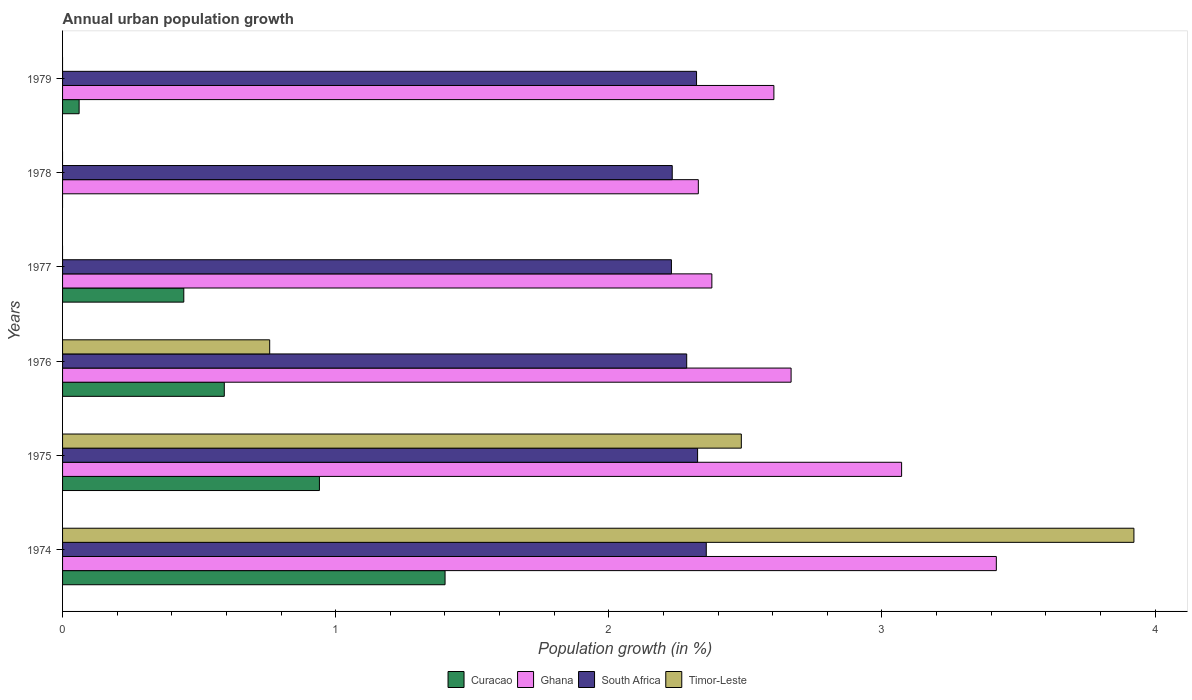Are the number of bars per tick equal to the number of legend labels?
Provide a succinct answer. No. How many bars are there on the 1st tick from the top?
Your response must be concise. 3. How many bars are there on the 2nd tick from the bottom?
Your response must be concise. 4. What is the label of the 3rd group of bars from the top?
Your response must be concise. 1977. In how many cases, is the number of bars for a given year not equal to the number of legend labels?
Provide a succinct answer. 3. What is the percentage of urban population growth in Timor-Leste in 1978?
Your answer should be very brief. 0. Across all years, what is the maximum percentage of urban population growth in Curacao?
Make the answer very short. 1.4. Across all years, what is the minimum percentage of urban population growth in South Africa?
Give a very brief answer. 2.23. In which year was the percentage of urban population growth in South Africa maximum?
Your response must be concise. 1974. What is the total percentage of urban population growth in Curacao in the graph?
Offer a terse response. 3.44. What is the difference between the percentage of urban population growth in Ghana in 1974 and that in 1978?
Provide a succinct answer. 1.09. What is the difference between the percentage of urban population growth in South Africa in 1978 and the percentage of urban population growth in Timor-Leste in 1974?
Give a very brief answer. -1.69. What is the average percentage of urban population growth in Timor-Leste per year?
Ensure brevity in your answer.  1.19. In the year 1977, what is the difference between the percentage of urban population growth in Curacao and percentage of urban population growth in Ghana?
Your response must be concise. -1.93. What is the ratio of the percentage of urban population growth in South Africa in 1974 to that in 1979?
Offer a terse response. 1.02. What is the difference between the highest and the second highest percentage of urban population growth in Ghana?
Your answer should be very brief. 0.35. What is the difference between the highest and the lowest percentage of urban population growth in South Africa?
Give a very brief answer. 0.13. Is the sum of the percentage of urban population growth in Ghana in 1974 and 1979 greater than the maximum percentage of urban population growth in Timor-Leste across all years?
Offer a terse response. Yes. Are all the bars in the graph horizontal?
Your response must be concise. Yes. Are the values on the major ticks of X-axis written in scientific E-notation?
Keep it short and to the point. No. Where does the legend appear in the graph?
Give a very brief answer. Bottom center. How many legend labels are there?
Your answer should be very brief. 4. How are the legend labels stacked?
Give a very brief answer. Horizontal. What is the title of the graph?
Give a very brief answer. Annual urban population growth. Does "Bhutan" appear as one of the legend labels in the graph?
Give a very brief answer. No. What is the label or title of the X-axis?
Keep it short and to the point. Population growth (in %). What is the label or title of the Y-axis?
Provide a succinct answer. Years. What is the Population growth (in %) of Curacao in 1974?
Make the answer very short. 1.4. What is the Population growth (in %) of Ghana in 1974?
Ensure brevity in your answer.  3.42. What is the Population growth (in %) in South Africa in 1974?
Your answer should be very brief. 2.36. What is the Population growth (in %) of Timor-Leste in 1974?
Your answer should be compact. 3.92. What is the Population growth (in %) in Curacao in 1975?
Make the answer very short. 0.94. What is the Population growth (in %) of Ghana in 1975?
Your response must be concise. 3.07. What is the Population growth (in %) of South Africa in 1975?
Offer a very short reply. 2.33. What is the Population growth (in %) of Timor-Leste in 1975?
Make the answer very short. 2.49. What is the Population growth (in %) of Curacao in 1976?
Offer a very short reply. 0.59. What is the Population growth (in %) of Ghana in 1976?
Your answer should be compact. 2.67. What is the Population growth (in %) in South Africa in 1976?
Your answer should be compact. 2.29. What is the Population growth (in %) in Timor-Leste in 1976?
Offer a terse response. 0.76. What is the Population growth (in %) in Curacao in 1977?
Your response must be concise. 0.44. What is the Population growth (in %) in Ghana in 1977?
Make the answer very short. 2.38. What is the Population growth (in %) of South Africa in 1977?
Provide a short and direct response. 2.23. What is the Population growth (in %) in Curacao in 1978?
Provide a succinct answer. 0. What is the Population growth (in %) of Ghana in 1978?
Offer a very short reply. 2.33. What is the Population growth (in %) of South Africa in 1978?
Your answer should be compact. 2.23. What is the Population growth (in %) of Curacao in 1979?
Offer a terse response. 0.06. What is the Population growth (in %) of Ghana in 1979?
Make the answer very short. 2.6. What is the Population growth (in %) of South Africa in 1979?
Provide a succinct answer. 2.32. What is the Population growth (in %) of Timor-Leste in 1979?
Offer a very short reply. 0. Across all years, what is the maximum Population growth (in %) of Curacao?
Your answer should be very brief. 1.4. Across all years, what is the maximum Population growth (in %) of Ghana?
Make the answer very short. 3.42. Across all years, what is the maximum Population growth (in %) in South Africa?
Make the answer very short. 2.36. Across all years, what is the maximum Population growth (in %) of Timor-Leste?
Offer a very short reply. 3.92. Across all years, what is the minimum Population growth (in %) of Curacao?
Provide a short and direct response. 0. Across all years, what is the minimum Population growth (in %) of Ghana?
Make the answer very short. 2.33. Across all years, what is the minimum Population growth (in %) of South Africa?
Keep it short and to the point. 2.23. Across all years, what is the minimum Population growth (in %) in Timor-Leste?
Offer a terse response. 0. What is the total Population growth (in %) of Curacao in the graph?
Your answer should be very brief. 3.44. What is the total Population growth (in %) of Ghana in the graph?
Offer a terse response. 16.47. What is the total Population growth (in %) of South Africa in the graph?
Give a very brief answer. 13.75. What is the total Population growth (in %) of Timor-Leste in the graph?
Give a very brief answer. 7.17. What is the difference between the Population growth (in %) of Curacao in 1974 and that in 1975?
Provide a short and direct response. 0.46. What is the difference between the Population growth (in %) of Ghana in 1974 and that in 1975?
Keep it short and to the point. 0.35. What is the difference between the Population growth (in %) in South Africa in 1974 and that in 1975?
Offer a terse response. 0.03. What is the difference between the Population growth (in %) of Timor-Leste in 1974 and that in 1975?
Your answer should be very brief. 1.44. What is the difference between the Population growth (in %) of Curacao in 1974 and that in 1976?
Your response must be concise. 0.81. What is the difference between the Population growth (in %) in Ghana in 1974 and that in 1976?
Your response must be concise. 0.75. What is the difference between the Population growth (in %) of South Africa in 1974 and that in 1976?
Provide a short and direct response. 0.07. What is the difference between the Population growth (in %) of Timor-Leste in 1974 and that in 1976?
Provide a short and direct response. 3.16. What is the difference between the Population growth (in %) in Curacao in 1974 and that in 1977?
Give a very brief answer. 0.96. What is the difference between the Population growth (in %) in Ghana in 1974 and that in 1977?
Make the answer very short. 1.04. What is the difference between the Population growth (in %) in South Africa in 1974 and that in 1977?
Give a very brief answer. 0.13. What is the difference between the Population growth (in %) in Ghana in 1974 and that in 1978?
Give a very brief answer. 1.09. What is the difference between the Population growth (in %) in South Africa in 1974 and that in 1978?
Your answer should be compact. 0.12. What is the difference between the Population growth (in %) in Curacao in 1974 and that in 1979?
Your answer should be compact. 1.34. What is the difference between the Population growth (in %) in Ghana in 1974 and that in 1979?
Offer a terse response. 0.81. What is the difference between the Population growth (in %) of South Africa in 1974 and that in 1979?
Your response must be concise. 0.04. What is the difference between the Population growth (in %) of Curacao in 1975 and that in 1976?
Keep it short and to the point. 0.35. What is the difference between the Population growth (in %) of Ghana in 1975 and that in 1976?
Your answer should be compact. 0.4. What is the difference between the Population growth (in %) in South Africa in 1975 and that in 1976?
Provide a short and direct response. 0.04. What is the difference between the Population growth (in %) in Timor-Leste in 1975 and that in 1976?
Ensure brevity in your answer.  1.73. What is the difference between the Population growth (in %) of Curacao in 1975 and that in 1977?
Offer a very short reply. 0.5. What is the difference between the Population growth (in %) of Ghana in 1975 and that in 1977?
Keep it short and to the point. 0.69. What is the difference between the Population growth (in %) in South Africa in 1975 and that in 1977?
Offer a very short reply. 0.1. What is the difference between the Population growth (in %) of Ghana in 1975 and that in 1978?
Give a very brief answer. 0.74. What is the difference between the Population growth (in %) of South Africa in 1975 and that in 1978?
Keep it short and to the point. 0.09. What is the difference between the Population growth (in %) of Curacao in 1975 and that in 1979?
Your response must be concise. 0.88. What is the difference between the Population growth (in %) of Ghana in 1975 and that in 1979?
Make the answer very short. 0.47. What is the difference between the Population growth (in %) in South Africa in 1975 and that in 1979?
Your answer should be compact. 0. What is the difference between the Population growth (in %) of Curacao in 1976 and that in 1977?
Provide a short and direct response. 0.15. What is the difference between the Population growth (in %) in Ghana in 1976 and that in 1977?
Your answer should be compact. 0.29. What is the difference between the Population growth (in %) of South Africa in 1976 and that in 1977?
Your answer should be very brief. 0.06. What is the difference between the Population growth (in %) in Ghana in 1976 and that in 1978?
Offer a terse response. 0.34. What is the difference between the Population growth (in %) in South Africa in 1976 and that in 1978?
Make the answer very short. 0.05. What is the difference between the Population growth (in %) in Curacao in 1976 and that in 1979?
Offer a very short reply. 0.53. What is the difference between the Population growth (in %) in Ghana in 1976 and that in 1979?
Provide a succinct answer. 0.06. What is the difference between the Population growth (in %) in South Africa in 1976 and that in 1979?
Provide a succinct answer. -0.04. What is the difference between the Population growth (in %) in Ghana in 1977 and that in 1978?
Make the answer very short. 0.05. What is the difference between the Population growth (in %) of South Africa in 1977 and that in 1978?
Your response must be concise. -0. What is the difference between the Population growth (in %) of Curacao in 1977 and that in 1979?
Give a very brief answer. 0.38. What is the difference between the Population growth (in %) of Ghana in 1977 and that in 1979?
Your answer should be compact. -0.23. What is the difference between the Population growth (in %) of South Africa in 1977 and that in 1979?
Offer a very short reply. -0.09. What is the difference between the Population growth (in %) in Ghana in 1978 and that in 1979?
Your answer should be compact. -0.28. What is the difference between the Population growth (in %) in South Africa in 1978 and that in 1979?
Give a very brief answer. -0.09. What is the difference between the Population growth (in %) in Curacao in 1974 and the Population growth (in %) in Ghana in 1975?
Provide a succinct answer. -1.67. What is the difference between the Population growth (in %) of Curacao in 1974 and the Population growth (in %) of South Africa in 1975?
Keep it short and to the point. -0.92. What is the difference between the Population growth (in %) of Curacao in 1974 and the Population growth (in %) of Timor-Leste in 1975?
Provide a short and direct response. -1.08. What is the difference between the Population growth (in %) of Ghana in 1974 and the Population growth (in %) of South Africa in 1975?
Your response must be concise. 1.09. What is the difference between the Population growth (in %) of Ghana in 1974 and the Population growth (in %) of Timor-Leste in 1975?
Your response must be concise. 0.93. What is the difference between the Population growth (in %) in South Africa in 1974 and the Population growth (in %) in Timor-Leste in 1975?
Keep it short and to the point. -0.13. What is the difference between the Population growth (in %) in Curacao in 1974 and the Population growth (in %) in Ghana in 1976?
Provide a short and direct response. -1.27. What is the difference between the Population growth (in %) of Curacao in 1974 and the Population growth (in %) of South Africa in 1976?
Offer a terse response. -0.88. What is the difference between the Population growth (in %) of Curacao in 1974 and the Population growth (in %) of Timor-Leste in 1976?
Your response must be concise. 0.64. What is the difference between the Population growth (in %) in Ghana in 1974 and the Population growth (in %) in South Africa in 1976?
Make the answer very short. 1.13. What is the difference between the Population growth (in %) in Ghana in 1974 and the Population growth (in %) in Timor-Leste in 1976?
Provide a short and direct response. 2.66. What is the difference between the Population growth (in %) in South Africa in 1974 and the Population growth (in %) in Timor-Leste in 1976?
Your response must be concise. 1.6. What is the difference between the Population growth (in %) of Curacao in 1974 and the Population growth (in %) of Ghana in 1977?
Provide a short and direct response. -0.98. What is the difference between the Population growth (in %) of Curacao in 1974 and the Population growth (in %) of South Africa in 1977?
Ensure brevity in your answer.  -0.83. What is the difference between the Population growth (in %) of Ghana in 1974 and the Population growth (in %) of South Africa in 1977?
Keep it short and to the point. 1.19. What is the difference between the Population growth (in %) in Curacao in 1974 and the Population growth (in %) in Ghana in 1978?
Your answer should be very brief. -0.93. What is the difference between the Population growth (in %) in Curacao in 1974 and the Population growth (in %) in South Africa in 1978?
Offer a terse response. -0.83. What is the difference between the Population growth (in %) of Ghana in 1974 and the Population growth (in %) of South Africa in 1978?
Give a very brief answer. 1.19. What is the difference between the Population growth (in %) of Curacao in 1974 and the Population growth (in %) of Ghana in 1979?
Make the answer very short. -1.2. What is the difference between the Population growth (in %) of Curacao in 1974 and the Population growth (in %) of South Africa in 1979?
Your response must be concise. -0.92. What is the difference between the Population growth (in %) in Ghana in 1974 and the Population growth (in %) in South Africa in 1979?
Give a very brief answer. 1.1. What is the difference between the Population growth (in %) of Curacao in 1975 and the Population growth (in %) of Ghana in 1976?
Your response must be concise. -1.73. What is the difference between the Population growth (in %) of Curacao in 1975 and the Population growth (in %) of South Africa in 1976?
Provide a short and direct response. -1.34. What is the difference between the Population growth (in %) in Curacao in 1975 and the Population growth (in %) in Timor-Leste in 1976?
Provide a succinct answer. 0.18. What is the difference between the Population growth (in %) of Ghana in 1975 and the Population growth (in %) of South Africa in 1976?
Ensure brevity in your answer.  0.79. What is the difference between the Population growth (in %) of Ghana in 1975 and the Population growth (in %) of Timor-Leste in 1976?
Ensure brevity in your answer.  2.31. What is the difference between the Population growth (in %) in South Africa in 1975 and the Population growth (in %) in Timor-Leste in 1976?
Your answer should be compact. 1.57. What is the difference between the Population growth (in %) in Curacao in 1975 and the Population growth (in %) in Ghana in 1977?
Your response must be concise. -1.44. What is the difference between the Population growth (in %) in Curacao in 1975 and the Population growth (in %) in South Africa in 1977?
Offer a terse response. -1.29. What is the difference between the Population growth (in %) of Ghana in 1975 and the Population growth (in %) of South Africa in 1977?
Provide a succinct answer. 0.84. What is the difference between the Population growth (in %) in Curacao in 1975 and the Population growth (in %) in Ghana in 1978?
Make the answer very short. -1.39. What is the difference between the Population growth (in %) in Curacao in 1975 and the Population growth (in %) in South Africa in 1978?
Your answer should be very brief. -1.29. What is the difference between the Population growth (in %) of Ghana in 1975 and the Population growth (in %) of South Africa in 1978?
Your answer should be compact. 0.84. What is the difference between the Population growth (in %) in Curacao in 1975 and the Population growth (in %) in Ghana in 1979?
Give a very brief answer. -1.66. What is the difference between the Population growth (in %) in Curacao in 1975 and the Population growth (in %) in South Africa in 1979?
Your response must be concise. -1.38. What is the difference between the Population growth (in %) of Ghana in 1975 and the Population growth (in %) of South Africa in 1979?
Your answer should be very brief. 0.75. What is the difference between the Population growth (in %) in Curacao in 1976 and the Population growth (in %) in Ghana in 1977?
Your answer should be compact. -1.79. What is the difference between the Population growth (in %) in Curacao in 1976 and the Population growth (in %) in South Africa in 1977?
Make the answer very short. -1.64. What is the difference between the Population growth (in %) in Ghana in 1976 and the Population growth (in %) in South Africa in 1977?
Offer a terse response. 0.44. What is the difference between the Population growth (in %) of Curacao in 1976 and the Population growth (in %) of Ghana in 1978?
Offer a very short reply. -1.74. What is the difference between the Population growth (in %) of Curacao in 1976 and the Population growth (in %) of South Africa in 1978?
Offer a terse response. -1.64. What is the difference between the Population growth (in %) in Ghana in 1976 and the Population growth (in %) in South Africa in 1978?
Your answer should be very brief. 0.44. What is the difference between the Population growth (in %) in Curacao in 1976 and the Population growth (in %) in Ghana in 1979?
Your response must be concise. -2.01. What is the difference between the Population growth (in %) of Curacao in 1976 and the Population growth (in %) of South Africa in 1979?
Your answer should be compact. -1.73. What is the difference between the Population growth (in %) of Ghana in 1976 and the Population growth (in %) of South Africa in 1979?
Offer a terse response. 0.35. What is the difference between the Population growth (in %) of Curacao in 1977 and the Population growth (in %) of Ghana in 1978?
Keep it short and to the point. -1.88. What is the difference between the Population growth (in %) in Curacao in 1977 and the Population growth (in %) in South Africa in 1978?
Offer a terse response. -1.79. What is the difference between the Population growth (in %) in Ghana in 1977 and the Population growth (in %) in South Africa in 1978?
Your response must be concise. 0.15. What is the difference between the Population growth (in %) in Curacao in 1977 and the Population growth (in %) in Ghana in 1979?
Give a very brief answer. -2.16. What is the difference between the Population growth (in %) of Curacao in 1977 and the Population growth (in %) of South Africa in 1979?
Your answer should be very brief. -1.88. What is the difference between the Population growth (in %) in Ghana in 1977 and the Population growth (in %) in South Africa in 1979?
Make the answer very short. 0.06. What is the difference between the Population growth (in %) in Ghana in 1978 and the Population growth (in %) in South Africa in 1979?
Your response must be concise. 0.01. What is the average Population growth (in %) in Curacao per year?
Keep it short and to the point. 0.57. What is the average Population growth (in %) of Ghana per year?
Give a very brief answer. 2.74. What is the average Population growth (in %) in South Africa per year?
Your answer should be compact. 2.29. What is the average Population growth (in %) of Timor-Leste per year?
Your answer should be compact. 1.19. In the year 1974, what is the difference between the Population growth (in %) in Curacao and Population growth (in %) in Ghana?
Your response must be concise. -2.02. In the year 1974, what is the difference between the Population growth (in %) in Curacao and Population growth (in %) in South Africa?
Offer a very short reply. -0.96. In the year 1974, what is the difference between the Population growth (in %) in Curacao and Population growth (in %) in Timor-Leste?
Give a very brief answer. -2.52. In the year 1974, what is the difference between the Population growth (in %) of Ghana and Population growth (in %) of South Africa?
Offer a very short reply. 1.06. In the year 1974, what is the difference between the Population growth (in %) of Ghana and Population growth (in %) of Timor-Leste?
Offer a terse response. -0.5. In the year 1974, what is the difference between the Population growth (in %) of South Africa and Population growth (in %) of Timor-Leste?
Give a very brief answer. -1.57. In the year 1975, what is the difference between the Population growth (in %) of Curacao and Population growth (in %) of Ghana?
Your response must be concise. -2.13. In the year 1975, what is the difference between the Population growth (in %) of Curacao and Population growth (in %) of South Africa?
Your answer should be very brief. -1.38. In the year 1975, what is the difference between the Population growth (in %) of Curacao and Population growth (in %) of Timor-Leste?
Make the answer very short. -1.54. In the year 1975, what is the difference between the Population growth (in %) of Ghana and Population growth (in %) of South Africa?
Provide a succinct answer. 0.75. In the year 1975, what is the difference between the Population growth (in %) in Ghana and Population growth (in %) in Timor-Leste?
Your answer should be compact. 0.59. In the year 1975, what is the difference between the Population growth (in %) of South Africa and Population growth (in %) of Timor-Leste?
Keep it short and to the point. -0.16. In the year 1976, what is the difference between the Population growth (in %) in Curacao and Population growth (in %) in Ghana?
Offer a terse response. -2.08. In the year 1976, what is the difference between the Population growth (in %) in Curacao and Population growth (in %) in South Africa?
Provide a succinct answer. -1.69. In the year 1976, what is the difference between the Population growth (in %) of Curacao and Population growth (in %) of Timor-Leste?
Your answer should be compact. -0.17. In the year 1976, what is the difference between the Population growth (in %) in Ghana and Population growth (in %) in South Africa?
Give a very brief answer. 0.38. In the year 1976, what is the difference between the Population growth (in %) in Ghana and Population growth (in %) in Timor-Leste?
Provide a succinct answer. 1.91. In the year 1976, what is the difference between the Population growth (in %) of South Africa and Population growth (in %) of Timor-Leste?
Your answer should be compact. 1.53. In the year 1977, what is the difference between the Population growth (in %) of Curacao and Population growth (in %) of Ghana?
Your response must be concise. -1.93. In the year 1977, what is the difference between the Population growth (in %) of Curacao and Population growth (in %) of South Africa?
Provide a succinct answer. -1.79. In the year 1977, what is the difference between the Population growth (in %) in Ghana and Population growth (in %) in South Africa?
Provide a succinct answer. 0.15. In the year 1978, what is the difference between the Population growth (in %) in Ghana and Population growth (in %) in South Africa?
Make the answer very short. 0.1. In the year 1979, what is the difference between the Population growth (in %) in Curacao and Population growth (in %) in Ghana?
Your answer should be very brief. -2.54. In the year 1979, what is the difference between the Population growth (in %) in Curacao and Population growth (in %) in South Africa?
Ensure brevity in your answer.  -2.26. In the year 1979, what is the difference between the Population growth (in %) of Ghana and Population growth (in %) of South Africa?
Make the answer very short. 0.28. What is the ratio of the Population growth (in %) of Curacao in 1974 to that in 1975?
Provide a succinct answer. 1.49. What is the ratio of the Population growth (in %) of Ghana in 1974 to that in 1975?
Offer a very short reply. 1.11. What is the ratio of the Population growth (in %) of South Africa in 1974 to that in 1975?
Keep it short and to the point. 1.01. What is the ratio of the Population growth (in %) of Timor-Leste in 1974 to that in 1975?
Ensure brevity in your answer.  1.58. What is the ratio of the Population growth (in %) in Curacao in 1974 to that in 1976?
Offer a terse response. 2.37. What is the ratio of the Population growth (in %) of Ghana in 1974 to that in 1976?
Offer a very short reply. 1.28. What is the ratio of the Population growth (in %) of South Africa in 1974 to that in 1976?
Make the answer very short. 1.03. What is the ratio of the Population growth (in %) in Timor-Leste in 1974 to that in 1976?
Your answer should be compact. 5.17. What is the ratio of the Population growth (in %) in Curacao in 1974 to that in 1977?
Make the answer very short. 3.15. What is the ratio of the Population growth (in %) in Ghana in 1974 to that in 1977?
Your answer should be very brief. 1.44. What is the ratio of the Population growth (in %) of South Africa in 1974 to that in 1977?
Provide a short and direct response. 1.06. What is the ratio of the Population growth (in %) of Ghana in 1974 to that in 1978?
Offer a very short reply. 1.47. What is the ratio of the Population growth (in %) in South Africa in 1974 to that in 1978?
Offer a terse response. 1.06. What is the ratio of the Population growth (in %) in Curacao in 1974 to that in 1979?
Your response must be concise. 23.1. What is the ratio of the Population growth (in %) in Ghana in 1974 to that in 1979?
Make the answer very short. 1.31. What is the ratio of the Population growth (in %) of South Africa in 1974 to that in 1979?
Offer a very short reply. 1.02. What is the ratio of the Population growth (in %) in Curacao in 1975 to that in 1976?
Your answer should be very brief. 1.59. What is the ratio of the Population growth (in %) of Ghana in 1975 to that in 1976?
Offer a terse response. 1.15. What is the ratio of the Population growth (in %) in South Africa in 1975 to that in 1976?
Provide a short and direct response. 1.02. What is the ratio of the Population growth (in %) of Timor-Leste in 1975 to that in 1976?
Your answer should be compact. 3.28. What is the ratio of the Population growth (in %) of Curacao in 1975 to that in 1977?
Offer a very short reply. 2.12. What is the ratio of the Population growth (in %) in Ghana in 1975 to that in 1977?
Ensure brevity in your answer.  1.29. What is the ratio of the Population growth (in %) of South Africa in 1975 to that in 1977?
Ensure brevity in your answer.  1.04. What is the ratio of the Population growth (in %) of Ghana in 1975 to that in 1978?
Offer a terse response. 1.32. What is the ratio of the Population growth (in %) in South Africa in 1975 to that in 1978?
Provide a succinct answer. 1.04. What is the ratio of the Population growth (in %) of Curacao in 1975 to that in 1979?
Your answer should be very brief. 15.51. What is the ratio of the Population growth (in %) of Ghana in 1975 to that in 1979?
Ensure brevity in your answer.  1.18. What is the ratio of the Population growth (in %) of Curacao in 1976 to that in 1977?
Your answer should be compact. 1.33. What is the ratio of the Population growth (in %) in Ghana in 1976 to that in 1977?
Make the answer very short. 1.12. What is the ratio of the Population growth (in %) in South Africa in 1976 to that in 1977?
Provide a short and direct response. 1.03. What is the ratio of the Population growth (in %) of Ghana in 1976 to that in 1978?
Your response must be concise. 1.15. What is the ratio of the Population growth (in %) of South Africa in 1976 to that in 1978?
Keep it short and to the point. 1.02. What is the ratio of the Population growth (in %) of Curacao in 1976 to that in 1979?
Make the answer very short. 9.77. What is the ratio of the Population growth (in %) of Ghana in 1976 to that in 1979?
Your response must be concise. 1.02. What is the ratio of the Population growth (in %) of South Africa in 1976 to that in 1979?
Offer a terse response. 0.98. What is the ratio of the Population growth (in %) of Ghana in 1977 to that in 1978?
Your response must be concise. 1.02. What is the ratio of the Population growth (in %) in South Africa in 1977 to that in 1978?
Your answer should be compact. 1. What is the ratio of the Population growth (in %) of Curacao in 1977 to that in 1979?
Keep it short and to the point. 7.32. What is the ratio of the Population growth (in %) of Ghana in 1977 to that in 1979?
Your response must be concise. 0.91. What is the ratio of the Population growth (in %) in South Africa in 1977 to that in 1979?
Your answer should be compact. 0.96. What is the ratio of the Population growth (in %) of Ghana in 1978 to that in 1979?
Make the answer very short. 0.89. What is the ratio of the Population growth (in %) of South Africa in 1978 to that in 1979?
Provide a short and direct response. 0.96. What is the difference between the highest and the second highest Population growth (in %) of Curacao?
Your answer should be compact. 0.46. What is the difference between the highest and the second highest Population growth (in %) in Ghana?
Offer a terse response. 0.35. What is the difference between the highest and the second highest Population growth (in %) of South Africa?
Your response must be concise. 0.03. What is the difference between the highest and the second highest Population growth (in %) in Timor-Leste?
Offer a very short reply. 1.44. What is the difference between the highest and the lowest Population growth (in %) of Curacao?
Keep it short and to the point. 1.4. What is the difference between the highest and the lowest Population growth (in %) of Ghana?
Keep it short and to the point. 1.09. What is the difference between the highest and the lowest Population growth (in %) in South Africa?
Give a very brief answer. 0.13. What is the difference between the highest and the lowest Population growth (in %) in Timor-Leste?
Keep it short and to the point. 3.92. 